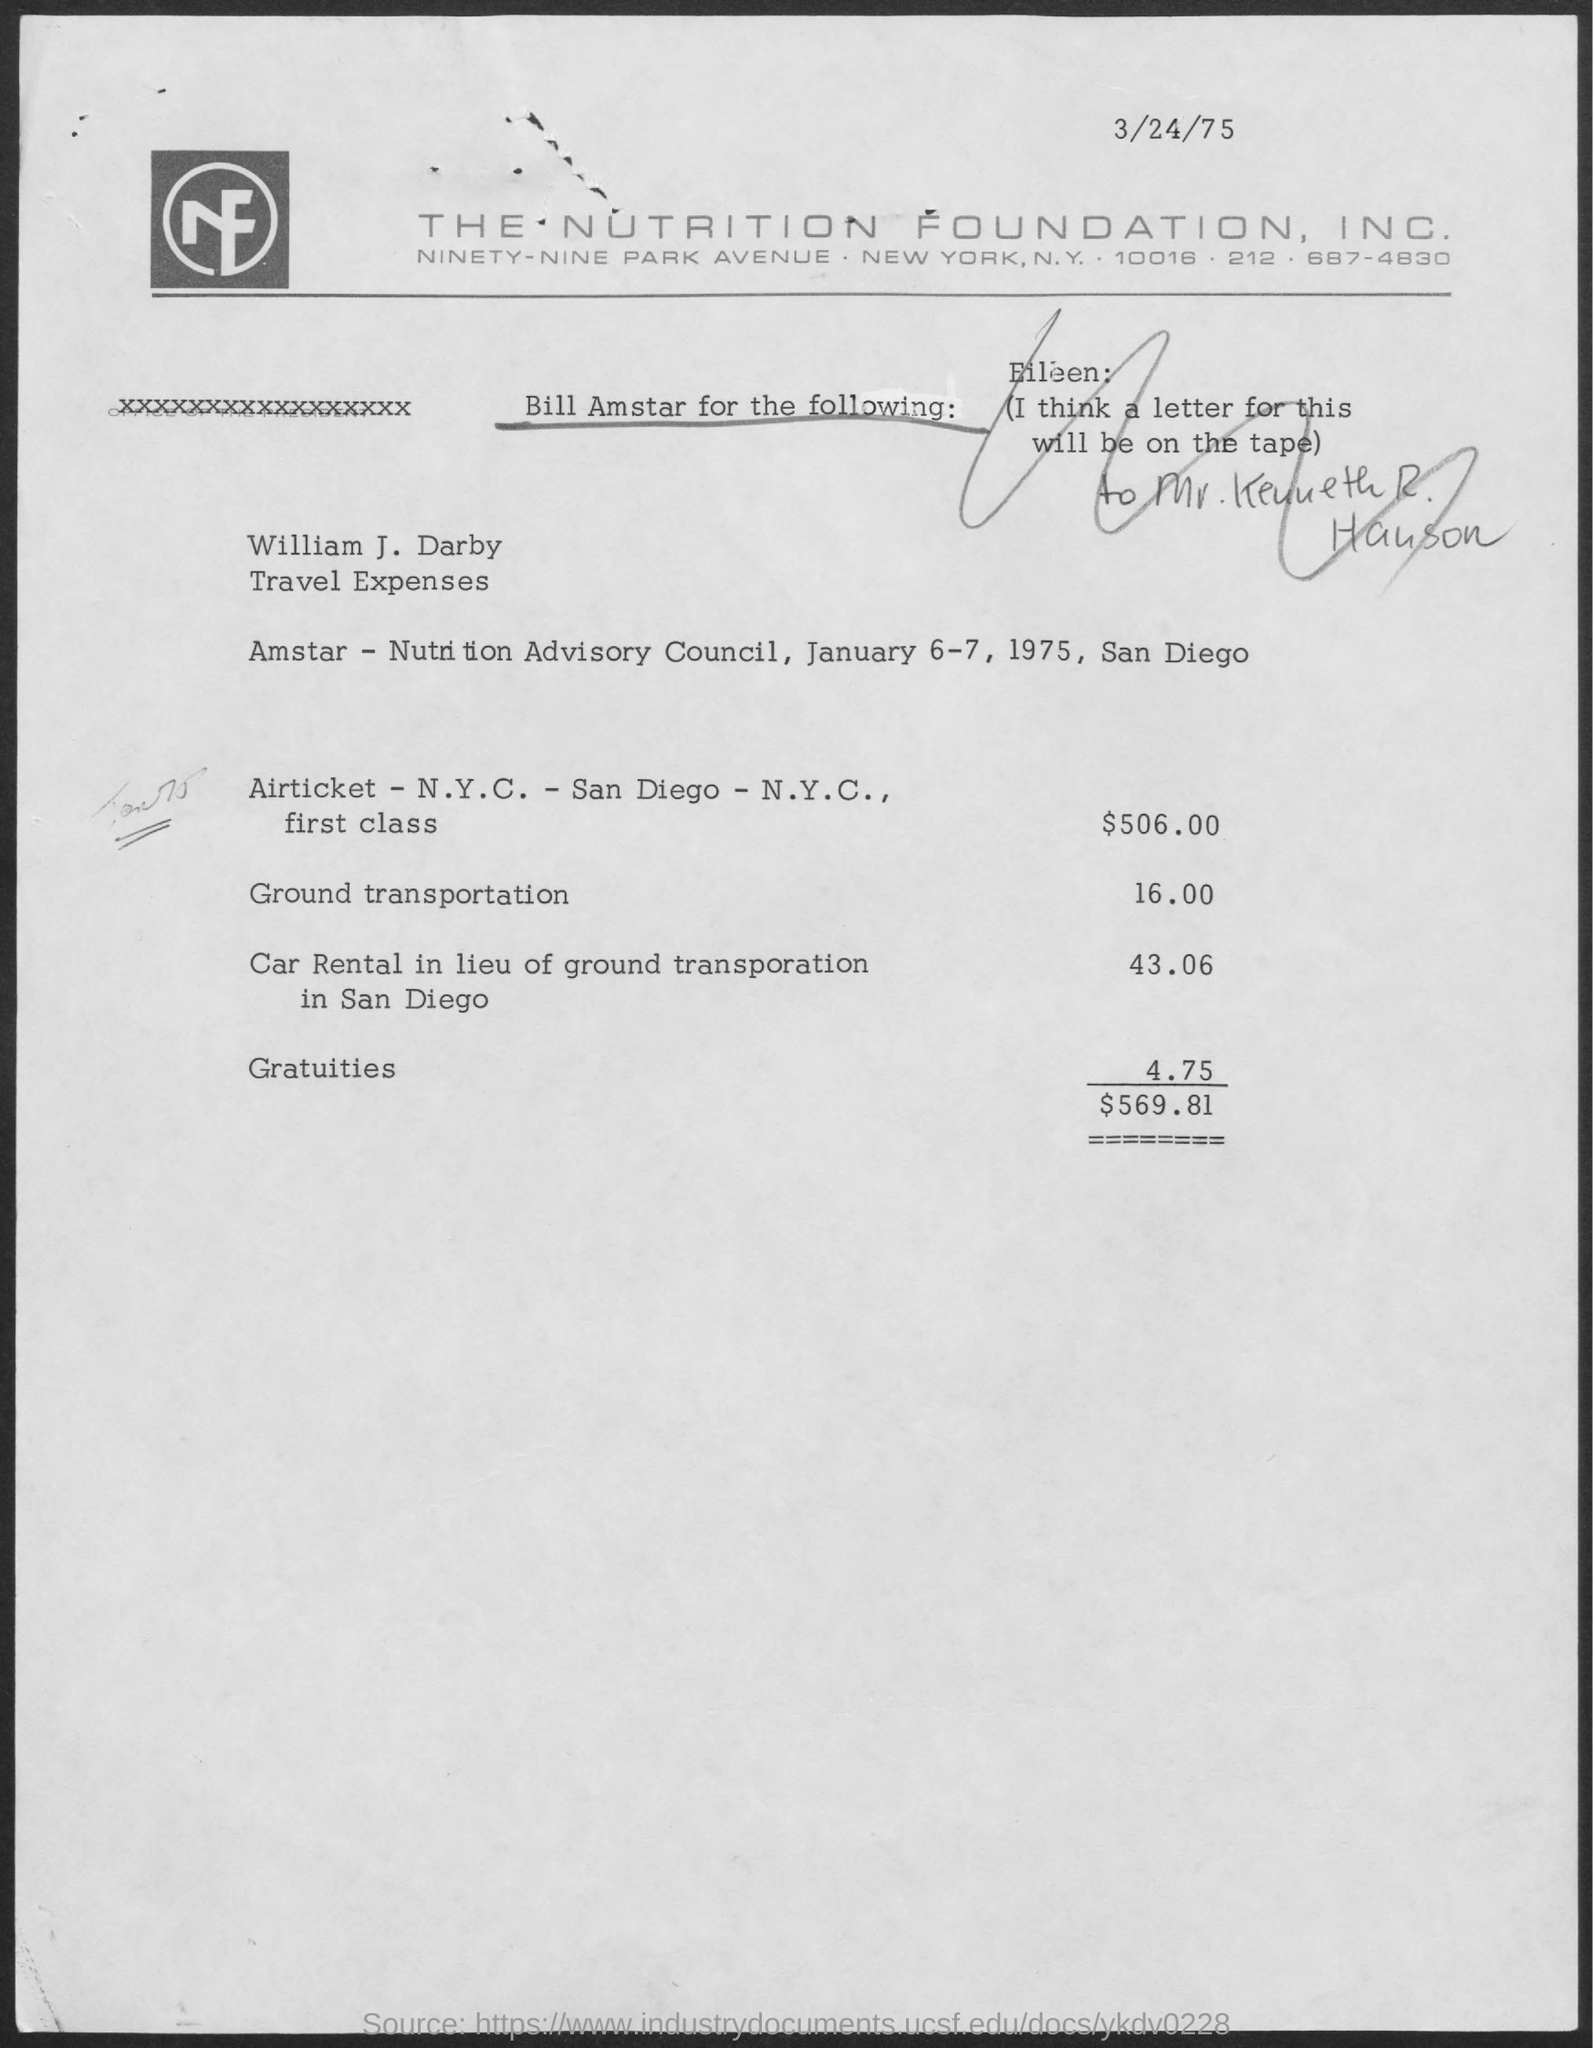Outline some significant characteristics in this image. The date mentioned at the top of the document is March 24, 1975. 